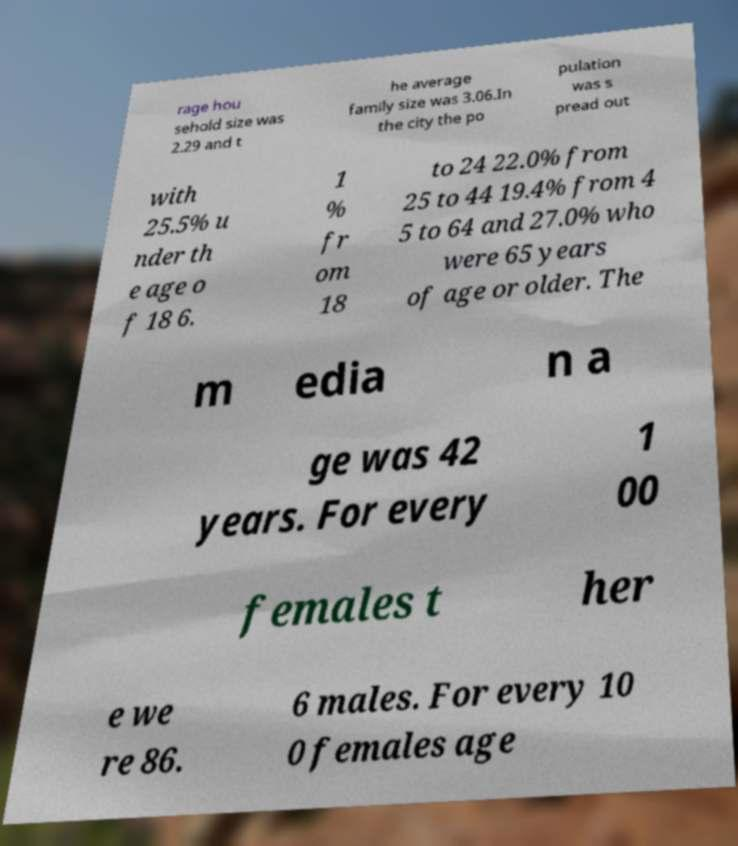Please identify and transcribe the text found in this image. rage hou sehold size was 2.29 and t he average family size was 3.06.In the city the po pulation was s pread out with 25.5% u nder th e age o f 18 6. 1 % fr om 18 to 24 22.0% from 25 to 44 19.4% from 4 5 to 64 and 27.0% who were 65 years of age or older. The m edia n a ge was 42 years. For every 1 00 females t her e we re 86. 6 males. For every 10 0 females age 